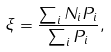<formula> <loc_0><loc_0><loc_500><loc_500>\xi = \frac { \sum _ { i } N _ { i } P _ { i } } { \sum _ { i } P _ { i } } ,</formula> 